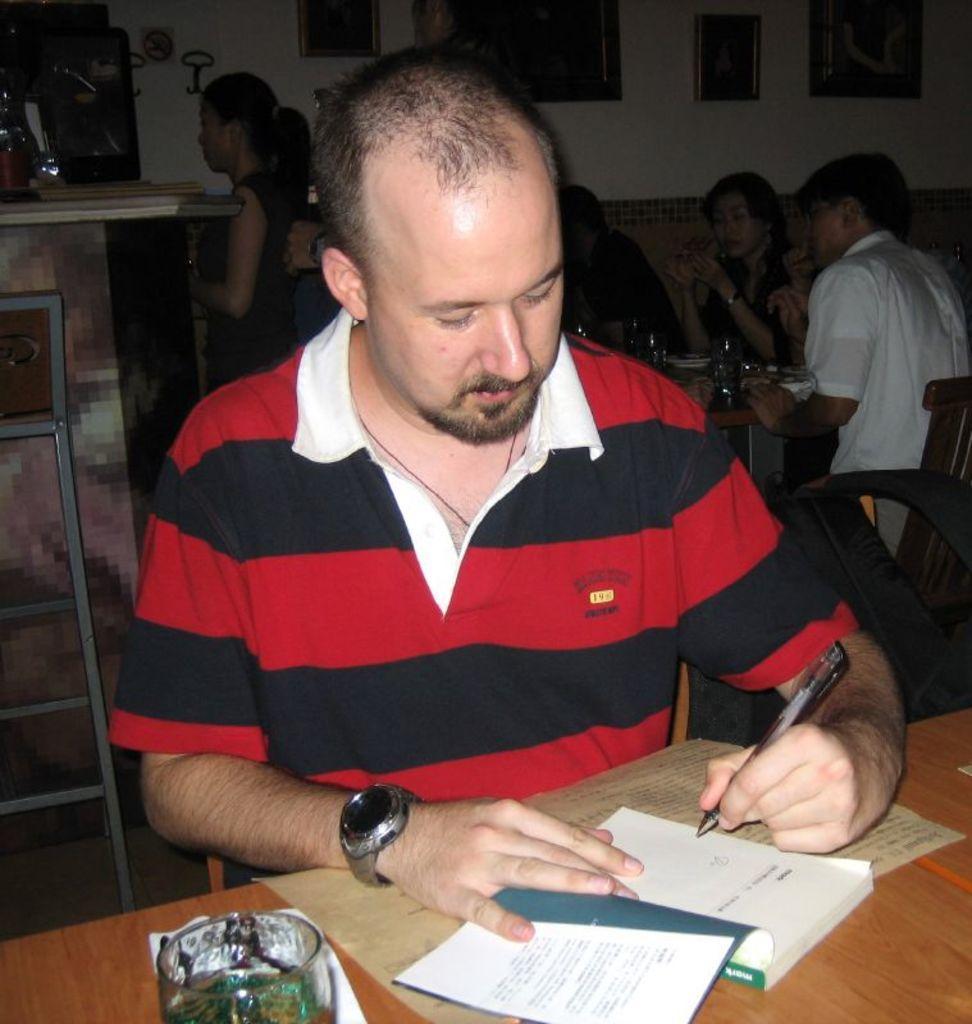How would you summarize this image in a sentence or two? In this image I can see a group of people are sitting on the chairs in front of a table, plates, glasses and a person is holding a pen in hand. In the background I can see a wall, photo frames and a table. This image is taken may be in a hall. 